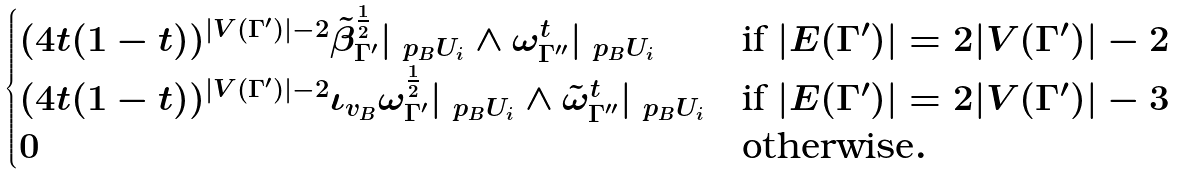Convert formula to latex. <formula><loc_0><loc_0><loc_500><loc_500>\begin{cases} ( 4 t ( 1 - t ) ) ^ { | V ( \Gamma ^ { \prime } ) | - 2 } \tilde { \beta } ^ { \frac { 1 } { 2 } } _ { \Gamma ^ { \prime } } | _ { \ p _ { B } U _ { i } } \wedge \omega ^ { t } _ { \Gamma ^ { \prime \prime } } | _ { \ p _ { B } U _ { i } } & \text {if } | E ( \Gamma ^ { \prime } ) | = 2 | V ( \Gamma ^ { \prime } ) | - 2 \\ ( 4 t ( 1 - t ) ) ^ { | V ( \Gamma ^ { \prime } ) | - 2 } \iota _ { v _ { B } } \omega ^ { \frac { 1 } { 2 } } _ { \Gamma ^ { \prime } } | _ { \ p _ { B } U _ { i } } \wedge \tilde { \omega } ^ { t } _ { \Gamma ^ { \prime \prime } } | _ { \ p _ { B } U _ { i } } & \text {if } | E ( \Gamma ^ { \prime } ) | = 2 | V ( \Gamma ^ { \prime } ) | - 3 \\ 0 & \text {otherwise} . \end{cases}</formula> 